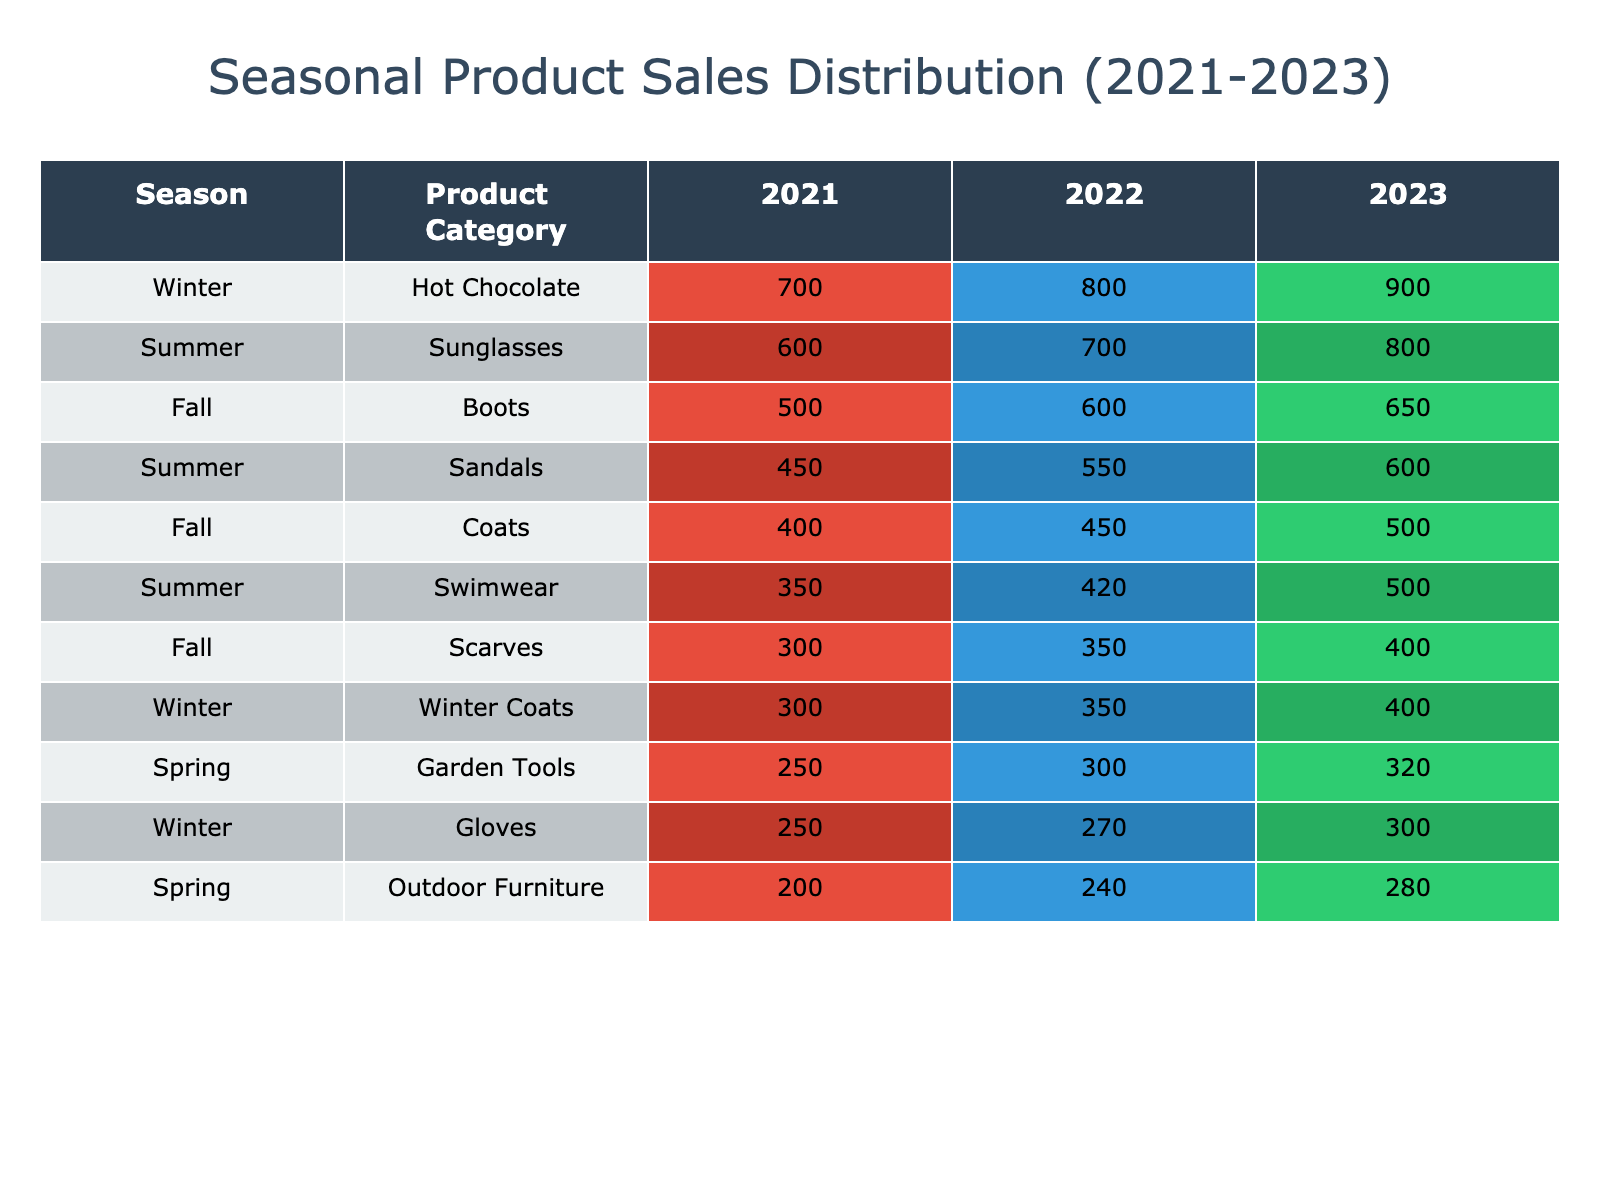What was the total number of units sold for Sunglasses in 2022? In 2022, the table shows that 700 units of Sunglasses were sold. There is only one entry for Sunglasses in 2022, making it straightforward to identify the total from that row.
Answer: 700 Which product category had the highest units sold in Winter 2023? In Winter 2023, Hot Chocolate had the highest units sold with 900 units. This is determined by comparing the numbers from the Winter category for all product types listed under the 2023 column.
Answer: Hot Chocolate What is the overall trend for Swimwear sales from 2021 to 2023? Swimwear sales increased from 350 units in 2021 to 500 units in 2023. This shows a total increase of 150 units over the three years, indicating a growing trend.
Answer: Increasing How many more units of Boots were sold in Fall 2023 than in Fall 2021? In Fall 2023, 650 units of Boots were sold, while in Fall 2021, 500 units were sold. The difference is calculated as 650 - 500 = 150 units more in 2023.
Answer: 150 Did the sales of Garden Tools in Spring show a consistent increase from 2021 to 2023? Examining the values: 250 units in 2021, 300 units in 2022, and 320 units in 2023 shows an overall increase each year (250 < 300 < 320). Hence, the sales did show a consistent increase.
Answer: Yes What was the total sales of Outdoor Furniture across all three years? The total sales for Outdoor Furniture are calculated by summing the units: 200 (2021) + 240 (2022) + 280 (2023) = 720 units sold across three years.
Answer: 720 In which year did Scarves sell the highest amount? By examining the sales numbers, Scarves sold 300 units in 2021, 350 units in 2022, and 400 units in 2023. Therefore, 2023 had the highest sales for Scarves.
Answer: 2023 What season had the lowest total sales across all product categories in 2021? Total for each season in 2021: Summer (1400), Fall (1200), Winter (1250), Spring (450). The lowest totals indicate that Spring had the least with 450 units sold in total across its categories.
Answer: Spring 